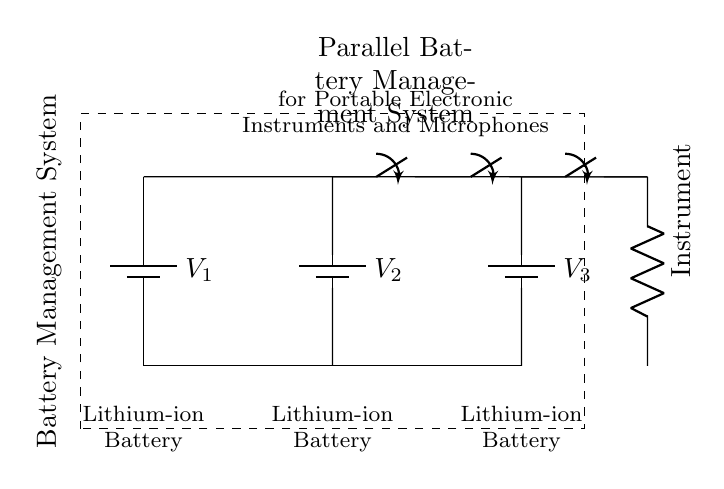What type of batteries are used in this circuit? The circuit shows three batteries labeled as Lithium-ion Batteries, indicating their type designed for rechargeable use in portable electronics.
Answer: Lithium-ion How many batteries are connected in parallel? The diagram clearly displays three separate battery symbols connected along the same top line, a characteristic arrangement of parallel connections, allowing the total voltage to remain stable while increasing capacity.
Answer: Three What is the purpose of the switches in the circuit? The switches in the circuit serve as a method to control the connection of each battery to the load (the instrument), allowing for maintenance or selection of power sources without disrupting performance.
Answer: Control power What happens if one battery fails in this parallel configuration? In a parallel battery system, if one battery fails, the remaining batteries can still provide power, which enhances reliability since the overall voltage remains unchanged while capacity decreases if the failed battery's capacity was part of the total.
Answer: Remaining batteries provide power What is the total voltage output if all batteries are operating? Each battery is assumed to provide a standard voltage (usually 3.7V for a lithium-ion), and since they are connected in parallel, the output voltage remains at this level for the entire system, not summed as in a series connection.
Answer: Same as one battery voltage What component is used to represent the load in the circuit? The circuit diagram features a resistor symbol representing the load, which corresponds to the portable electronic instrument being powered by the parallel battery management system.
Answer: Instrument 